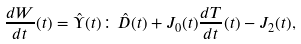Convert formula to latex. <formula><loc_0><loc_0><loc_500><loc_500>\frac { d W } { d t } ( t ) = \hat { \Upsilon } ( t ) \colon \hat { D } ( t ) + J _ { 0 } ( t ) \frac { d T } { d t } ( t ) - J _ { 2 } ( t ) ,</formula> 